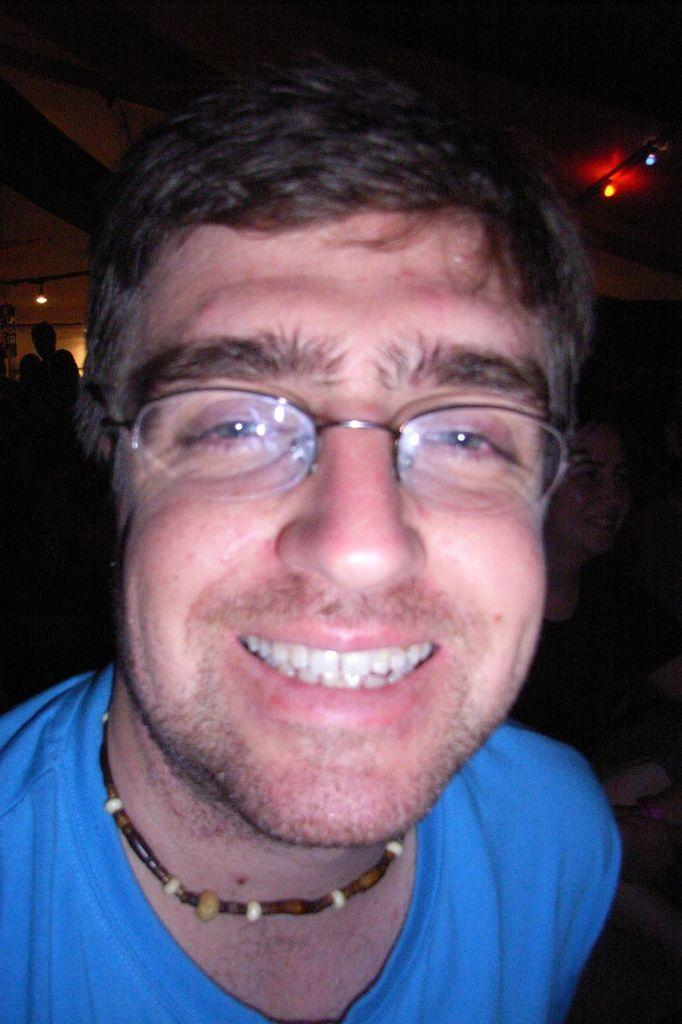What is the main subject of the image? There is a person in the image. Can you describe the person's clothing? The person is wearing a blue t-shirt. What accessory is the person wearing? The person is wearing spectacles. What else can be seen in the image besides the person? There are people in the background of the image. Can you tell me how many toads are sitting on the person's head in the image? There are no toads present in the image; the person is wearing spectacles, not toads. 